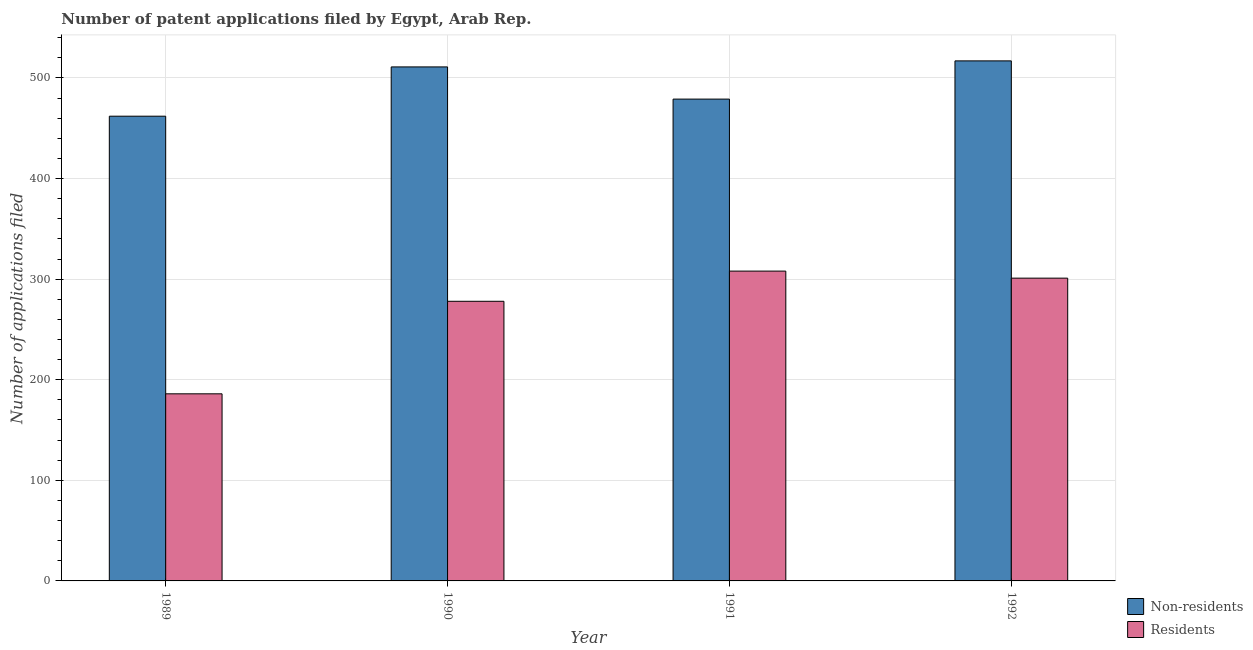How many different coloured bars are there?
Give a very brief answer. 2. How many groups of bars are there?
Provide a succinct answer. 4. Are the number of bars per tick equal to the number of legend labels?
Offer a very short reply. Yes. Are the number of bars on each tick of the X-axis equal?
Your response must be concise. Yes. How many bars are there on the 3rd tick from the left?
Offer a very short reply. 2. How many bars are there on the 3rd tick from the right?
Your answer should be compact. 2. What is the label of the 2nd group of bars from the left?
Offer a very short reply. 1990. In how many cases, is the number of bars for a given year not equal to the number of legend labels?
Make the answer very short. 0. What is the number of patent applications by residents in 1991?
Give a very brief answer. 308. Across all years, what is the maximum number of patent applications by residents?
Keep it short and to the point. 308. Across all years, what is the minimum number of patent applications by residents?
Keep it short and to the point. 186. In which year was the number of patent applications by non residents maximum?
Your response must be concise. 1992. What is the total number of patent applications by non residents in the graph?
Provide a succinct answer. 1969. What is the difference between the number of patent applications by residents in 1991 and that in 1992?
Give a very brief answer. 7. What is the difference between the number of patent applications by residents in 1990 and the number of patent applications by non residents in 1991?
Keep it short and to the point. -30. What is the average number of patent applications by non residents per year?
Your answer should be compact. 492.25. In the year 1991, what is the difference between the number of patent applications by non residents and number of patent applications by residents?
Offer a terse response. 0. What is the ratio of the number of patent applications by residents in 1991 to that in 1992?
Your answer should be compact. 1.02. What is the difference between the highest and the second highest number of patent applications by residents?
Give a very brief answer. 7. What is the difference between the highest and the lowest number of patent applications by non residents?
Ensure brevity in your answer.  55. Is the sum of the number of patent applications by non residents in 1989 and 1991 greater than the maximum number of patent applications by residents across all years?
Your answer should be very brief. Yes. What does the 2nd bar from the left in 1991 represents?
Make the answer very short. Residents. What does the 2nd bar from the right in 1991 represents?
Ensure brevity in your answer.  Non-residents. How many bars are there?
Offer a very short reply. 8. What is the difference between two consecutive major ticks on the Y-axis?
Ensure brevity in your answer.  100. Are the values on the major ticks of Y-axis written in scientific E-notation?
Give a very brief answer. No. Does the graph contain any zero values?
Offer a terse response. No. Where does the legend appear in the graph?
Give a very brief answer. Bottom right. How are the legend labels stacked?
Offer a very short reply. Vertical. What is the title of the graph?
Give a very brief answer. Number of patent applications filed by Egypt, Arab Rep. What is the label or title of the Y-axis?
Ensure brevity in your answer.  Number of applications filed. What is the Number of applications filed of Non-residents in 1989?
Give a very brief answer. 462. What is the Number of applications filed of Residents in 1989?
Ensure brevity in your answer.  186. What is the Number of applications filed of Non-residents in 1990?
Make the answer very short. 511. What is the Number of applications filed in Residents in 1990?
Your answer should be very brief. 278. What is the Number of applications filed in Non-residents in 1991?
Offer a very short reply. 479. What is the Number of applications filed of Residents in 1991?
Your answer should be compact. 308. What is the Number of applications filed in Non-residents in 1992?
Offer a very short reply. 517. What is the Number of applications filed in Residents in 1992?
Keep it short and to the point. 301. Across all years, what is the maximum Number of applications filed in Non-residents?
Ensure brevity in your answer.  517. Across all years, what is the maximum Number of applications filed in Residents?
Your answer should be compact. 308. Across all years, what is the minimum Number of applications filed in Non-residents?
Ensure brevity in your answer.  462. Across all years, what is the minimum Number of applications filed of Residents?
Your response must be concise. 186. What is the total Number of applications filed of Non-residents in the graph?
Offer a terse response. 1969. What is the total Number of applications filed in Residents in the graph?
Offer a very short reply. 1073. What is the difference between the Number of applications filed of Non-residents in 1989 and that in 1990?
Provide a succinct answer. -49. What is the difference between the Number of applications filed of Residents in 1989 and that in 1990?
Keep it short and to the point. -92. What is the difference between the Number of applications filed of Non-residents in 1989 and that in 1991?
Your answer should be compact. -17. What is the difference between the Number of applications filed of Residents in 1989 and that in 1991?
Your answer should be compact. -122. What is the difference between the Number of applications filed of Non-residents in 1989 and that in 1992?
Provide a succinct answer. -55. What is the difference between the Number of applications filed in Residents in 1989 and that in 1992?
Ensure brevity in your answer.  -115. What is the difference between the Number of applications filed in Non-residents in 1990 and that in 1991?
Your answer should be very brief. 32. What is the difference between the Number of applications filed in Non-residents in 1990 and that in 1992?
Provide a succinct answer. -6. What is the difference between the Number of applications filed in Non-residents in 1991 and that in 1992?
Provide a succinct answer. -38. What is the difference between the Number of applications filed of Residents in 1991 and that in 1992?
Ensure brevity in your answer.  7. What is the difference between the Number of applications filed of Non-residents in 1989 and the Number of applications filed of Residents in 1990?
Provide a short and direct response. 184. What is the difference between the Number of applications filed in Non-residents in 1989 and the Number of applications filed in Residents in 1991?
Make the answer very short. 154. What is the difference between the Number of applications filed in Non-residents in 1989 and the Number of applications filed in Residents in 1992?
Make the answer very short. 161. What is the difference between the Number of applications filed in Non-residents in 1990 and the Number of applications filed in Residents in 1991?
Keep it short and to the point. 203. What is the difference between the Number of applications filed of Non-residents in 1990 and the Number of applications filed of Residents in 1992?
Your response must be concise. 210. What is the difference between the Number of applications filed in Non-residents in 1991 and the Number of applications filed in Residents in 1992?
Give a very brief answer. 178. What is the average Number of applications filed of Non-residents per year?
Make the answer very short. 492.25. What is the average Number of applications filed of Residents per year?
Offer a very short reply. 268.25. In the year 1989, what is the difference between the Number of applications filed of Non-residents and Number of applications filed of Residents?
Offer a terse response. 276. In the year 1990, what is the difference between the Number of applications filed of Non-residents and Number of applications filed of Residents?
Your response must be concise. 233. In the year 1991, what is the difference between the Number of applications filed of Non-residents and Number of applications filed of Residents?
Give a very brief answer. 171. In the year 1992, what is the difference between the Number of applications filed of Non-residents and Number of applications filed of Residents?
Provide a succinct answer. 216. What is the ratio of the Number of applications filed in Non-residents in 1989 to that in 1990?
Provide a short and direct response. 0.9. What is the ratio of the Number of applications filed in Residents in 1989 to that in 1990?
Provide a short and direct response. 0.67. What is the ratio of the Number of applications filed of Non-residents in 1989 to that in 1991?
Give a very brief answer. 0.96. What is the ratio of the Number of applications filed of Residents in 1989 to that in 1991?
Your answer should be very brief. 0.6. What is the ratio of the Number of applications filed of Non-residents in 1989 to that in 1992?
Provide a short and direct response. 0.89. What is the ratio of the Number of applications filed in Residents in 1989 to that in 1992?
Your answer should be very brief. 0.62. What is the ratio of the Number of applications filed of Non-residents in 1990 to that in 1991?
Your answer should be compact. 1.07. What is the ratio of the Number of applications filed of Residents in 1990 to that in 1991?
Provide a short and direct response. 0.9. What is the ratio of the Number of applications filed in Non-residents in 1990 to that in 1992?
Provide a succinct answer. 0.99. What is the ratio of the Number of applications filed of Residents in 1990 to that in 1992?
Your response must be concise. 0.92. What is the ratio of the Number of applications filed of Non-residents in 1991 to that in 1992?
Offer a very short reply. 0.93. What is the ratio of the Number of applications filed in Residents in 1991 to that in 1992?
Ensure brevity in your answer.  1.02. What is the difference between the highest and the second highest Number of applications filed in Non-residents?
Offer a very short reply. 6. What is the difference between the highest and the second highest Number of applications filed in Residents?
Offer a terse response. 7. What is the difference between the highest and the lowest Number of applications filed in Residents?
Your answer should be very brief. 122. 